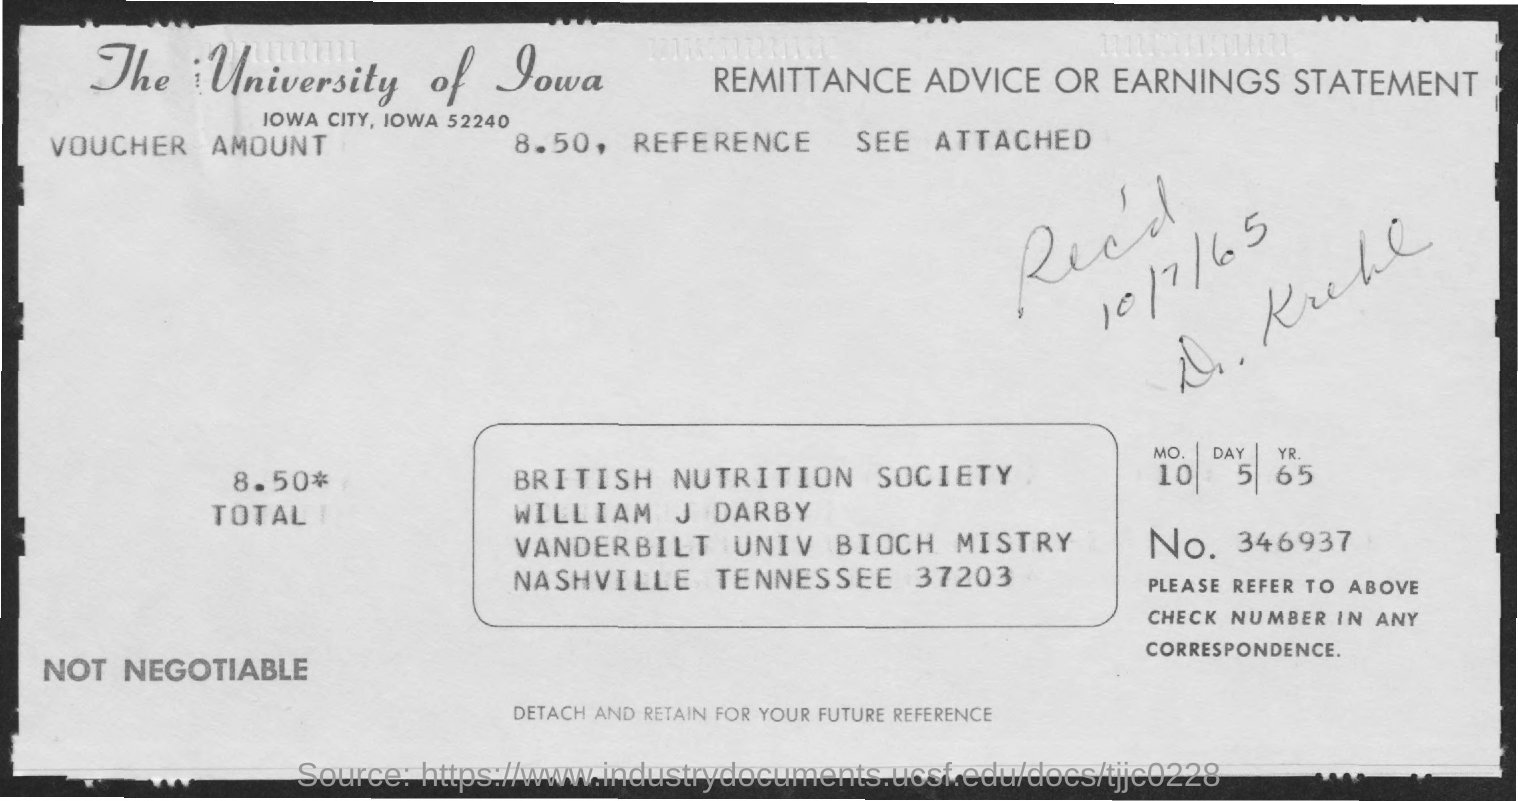What is the received date mentioned in the statement?
Make the answer very short. 10/7/65. What is the Check number mentioned in the statement?
Keep it short and to the point. 346937. What is the voucher amount given in the statement?
Make the answer very short. 8.50. Which University is mentioned in the header of the document?
Make the answer very short. The university of iowa. 